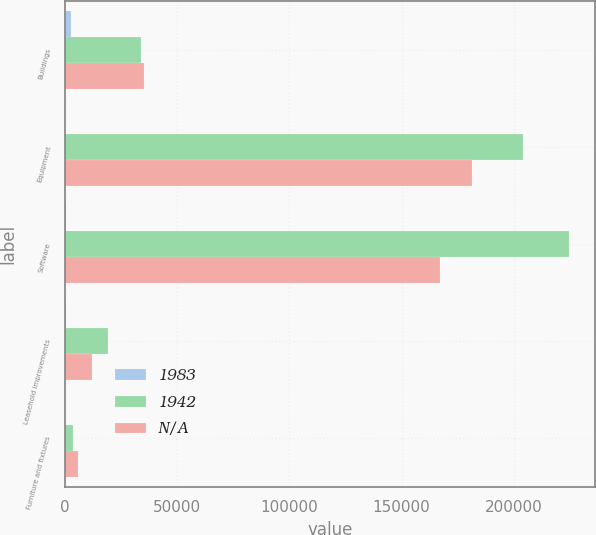<chart> <loc_0><loc_0><loc_500><loc_500><stacked_bar_chart><ecel><fcel>Buildings<fcel>Equipment<fcel>Software<fcel>Leasehold improvements<fcel>Furniture and fixtures<nl><fcel>1983<fcel>2530<fcel>210<fcel>510<fcel>515<fcel>57<nl><fcel>1942<fcel>33996<fcel>204102<fcel>224766<fcel>19399<fcel>3809<nl><fcel>nan<fcel>35216<fcel>181316<fcel>167084<fcel>12278<fcel>5796<nl></chart> 